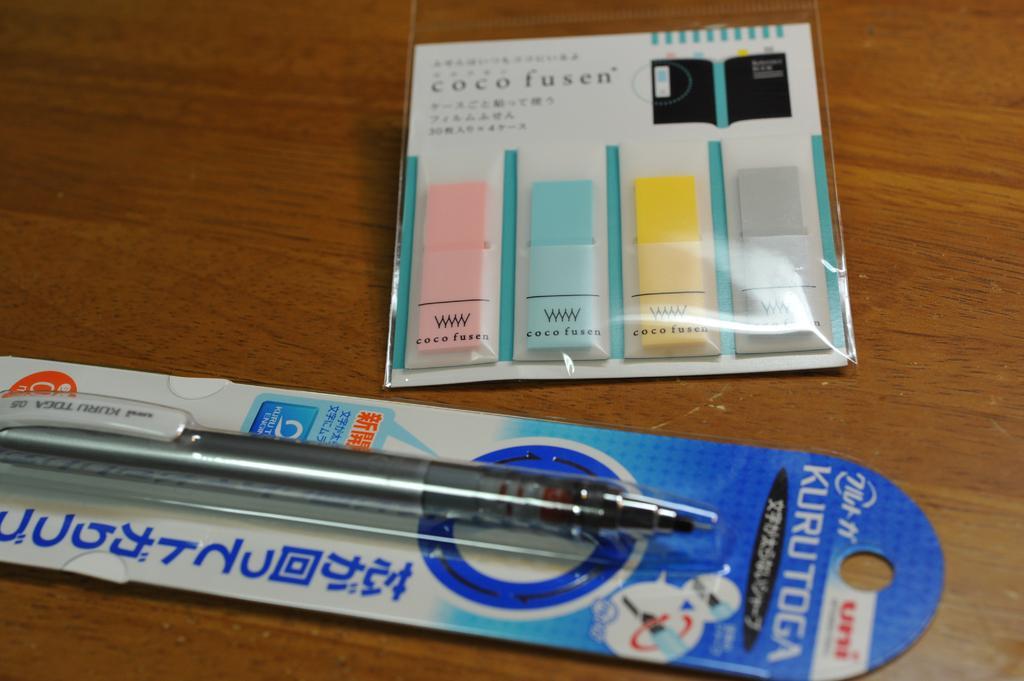How would you summarize this image in a sentence or two? In this picture we can see a pen and sticky notes. 